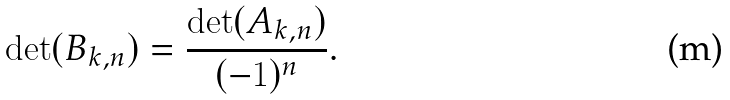<formula> <loc_0><loc_0><loc_500><loc_500>\det ( B _ { k , n } ) = \frac { \det ( A _ { k , n } ) } { ( - 1 ) ^ { n } } .</formula> 